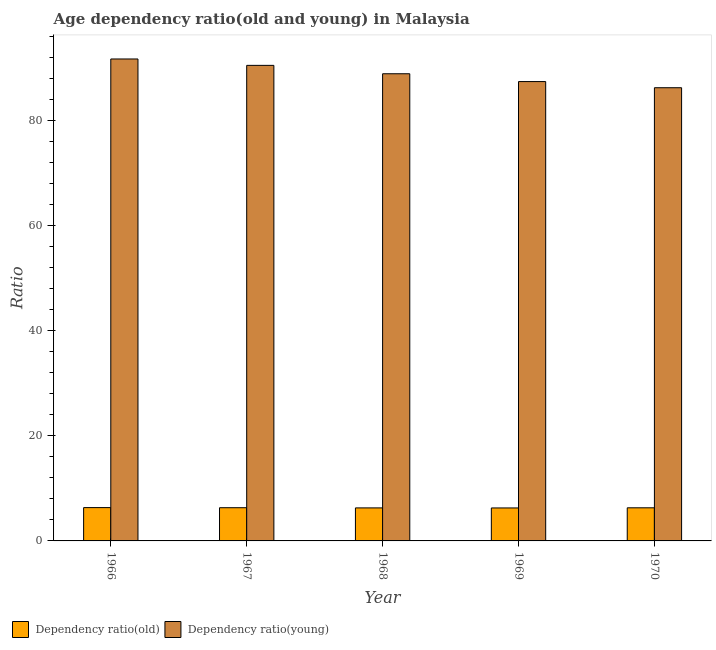How many groups of bars are there?
Ensure brevity in your answer.  5. Are the number of bars per tick equal to the number of legend labels?
Your answer should be compact. Yes. Are the number of bars on each tick of the X-axis equal?
Ensure brevity in your answer.  Yes. How many bars are there on the 3rd tick from the left?
Provide a short and direct response. 2. What is the label of the 1st group of bars from the left?
Your response must be concise. 1966. In how many cases, is the number of bars for a given year not equal to the number of legend labels?
Offer a terse response. 0. What is the age dependency ratio(old) in 1970?
Offer a very short reply. 6.3. Across all years, what is the maximum age dependency ratio(old)?
Your answer should be compact. 6.34. Across all years, what is the minimum age dependency ratio(old)?
Offer a very short reply. 6.27. In which year was the age dependency ratio(young) maximum?
Give a very brief answer. 1966. In which year was the age dependency ratio(old) minimum?
Offer a very short reply. 1969. What is the total age dependency ratio(young) in the graph?
Your response must be concise. 444.66. What is the difference between the age dependency ratio(young) in 1966 and that in 1969?
Provide a short and direct response. 4.3. What is the difference between the age dependency ratio(old) in 1969 and the age dependency ratio(young) in 1966?
Keep it short and to the point. -0.07. What is the average age dependency ratio(young) per year?
Ensure brevity in your answer.  88.93. In the year 1967, what is the difference between the age dependency ratio(old) and age dependency ratio(young)?
Offer a terse response. 0. What is the ratio of the age dependency ratio(young) in 1966 to that in 1969?
Your response must be concise. 1.05. Is the age dependency ratio(young) in 1966 less than that in 1969?
Your answer should be compact. No. Is the difference between the age dependency ratio(young) in 1968 and 1969 greater than the difference between the age dependency ratio(old) in 1968 and 1969?
Provide a short and direct response. No. What is the difference between the highest and the second highest age dependency ratio(old)?
Ensure brevity in your answer.  0.02. What is the difference between the highest and the lowest age dependency ratio(old)?
Offer a very short reply. 0.07. In how many years, is the age dependency ratio(old) greater than the average age dependency ratio(old) taken over all years?
Offer a very short reply. 2. Is the sum of the age dependency ratio(old) in 1966 and 1970 greater than the maximum age dependency ratio(young) across all years?
Your answer should be very brief. Yes. What does the 1st bar from the left in 1966 represents?
Your answer should be very brief. Dependency ratio(old). What does the 1st bar from the right in 1968 represents?
Your response must be concise. Dependency ratio(young). Does the graph contain any zero values?
Ensure brevity in your answer.  No. Does the graph contain grids?
Give a very brief answer. No. Where does the legend appear in the graph?
Your response must be concise. Bottom left. How many legend labels are there?
Your answer should be compact. 2. What is the title of the graph?
Ensure brevity in your answer.  Age dependency ratio(old and young) in Malaysia. What is the label or title of the X-axis?
Your answer should be compact. Year. What is the label or title of the Y-axis?
Ensure brevity in your answer.  Ratio. What is the Ratio of Dependency ratio(old) in 1966?
Make the answer very short. 6.34. What is the Ratio of Dependency ratio(young) in 1966?
Give a very brief answer. 91.69. What is the Ratio of Dependency ratio(old) in 1967?
Provide a short and direct response. 6.32. What is the Ratio in Dependency ratio(young) in 1967?
Your response must be concise. 90.48. What is the Ratio of Dependency ratio(old) in 1968?
Make the answer very short. 6.28. What is the Ratio of Dependency ratio(young) in 1968?
Offer a very short reply. 88.88. What is the Ratio of Dependency ratio(old) in 1969?
Your response must be concise. 6.27. What is the Ratio of Dependency ratio(young) in 1969?
Your answer should be compact. 87.39. What is the Ratio in Dependency ratio(old) in 1970?
Provide a succinct answer. 6.3. What is the Ratio of Dependency ratio(young) in 1970?
Ensure brevity in your answer.  86.22. Across all years, what is the maximum Ratio of Dependency ratio(old)?
Your response must be concise. 6.34. Across all years, what is the maximum Ratio in Dependency ratio(young)?
Provide a succinct answer. 91.69. Across all years, what is the minimum Ratio of Dependency ratio(old)?
Offer a terse response. 6.27. Across all years, what is the minimum Ratio in Dependency ratio(young)?
Your answer should be compact. 86.22. What is the total Ratio of Dependency ratio(old) in the graph?
Your answer should be very brief. 31.52. What is the total Ratio of Dependency ratio(young) in the graph?
Ensure brevity in your answer.  444.66. What is the difference between the Ratio in Dependency ratio(old) in 1966 and that in 1967?
Offer a very short reply. 0.02. What is the difference between the Ratio of Dependency ratio(young) in 1966 and that in 1967?
Your response must be concise. 1.22. What is the difference between the Ratio of Dependency ratio(old) in 1966 and that in 1968?
Offer a very short reply. 0.06. What is the difference between the Ratio in Dependency ratio(young) in 1966 and that in 1968?
Give a very brief answer. 2.81. What is the difference between the Ratio of Dependency ratio(old) in 1966 and that in 1969?
Your response must be concise. 0.07. What is the difference between the Ratio in Dependency ratio(young) in 1966 and that in 1969?
Your response must be concise. 4.3. What is the difference between the Ratio in Dependency ratio(old) in 1966 and that in 1970?
Provide a succinct answer. 0.04. What is the difference between the Ratio in Dependency ratio(young) in 1966 and that in 1970?
Your answer should be compact. 5.47. What is the difference between the Ratio in Dependency ratio(old) in 1967 and that in 1968?
Offer a terse response. 0.03. What is the difference between the Ratio of Dependency ratio(young) in 1967 and that in 1968?
Your response must be concise. 1.59. What is the difference between the Ratio in Dependency ratio(old) in 1967 and that in 1969?
Offer a terse response. 0.04. What is the difference between the Ratio of Dependency ratio(young) in 1967 and that in 1969?
Offer a very short reply. 3.08. What is the difference between the Ratio of Dependency ratio(old) in 1967 and that in 1970?
Make the answer very short. 0.02. What is the difference between the Ratio in Dependency ratio(young) in 1967 and that in 1970?
Ensure brevity in your answer.  4.25. What is the difference between the Ratio of Dependency ratio(old) in 1968 and that in 1969?
Ensure brevity in your answer.  0.01. What is the difference between the Ratio in Dependency ratio(young) in 1968 and that in 1969?
Give a very brief answer. 1.49. What is the difference between the Ratio of Dependency ratio(old) in 1968 and that in 1970?
Keep it short and to the point. -0.02. What is the difference between the Ratio of Dependency ratio(young) in 1968 and that in 1970?
Make the answer very short. 2.66. What is the difference between the Ratio in Dependency ratio(old) in 1969 and that in 1970?
Offer a terse response. -0.03. What is the difference between the Ratio in Dependency ratio(young) in 1969 and that in 1970?
Offer a terse response. 1.17. What is the difference between the Ratio of Dependency ratio(old) in 1966 and the Ratio of Dependency ratio(young) in 1967?
Your answer should be compact. -84.14. What is the difference between the Ratio in Dependency ratio(old) in 1966 and the Ratio in Dependency ratio(young) in 1968?
Offer a terse response. -82.54. What is the difference between the Ratio of Dependency ratio(old) in 1966 and the Ratio of Dependency ratio(young) in 1969?
Offer a very short reply. -81.05. What is the difference between the Ratio in Dependency ratio(old) in 1966 and the Ratio in Dependency ratio(young) in 1970?
Ensure brevity in your answer.  -79.88. What is the difference between the Ratio of Dependency ratio(old) in 1967 and the Ratio of Dependency ratio(young) in 1968?
Keep it short and to the point. -82.56. What is the difference between the Ratio in Dependency ratio(old) in 1967 and the Ratio in Dependency ratio(young) in 1969?
Your answer should be very brief. -81.07. What is the difference between the Ratio of Dependency ratio(old) in 1967 and the Ratio of Dependency ratio(young) in 1970?
Offer a terse response. -79.91. What is the difference between the Ratio in Dependency ratio(old) in 1968 and the Ratio in Dependency ratio(young) in 1969?
Provide a short and direct response. -81.11. What is the difference between the Ratio of Dependency ratio(old) in 1968 and the Ratio of Dependency ratio(young) in 1970?
Ensure brevity in your answer.  -79.94. What is the difference between the Ratio of Dependency ratio(old) in 1969 and the Ratio of Dependency ratio(young) in 1970?
Offer a terse response. -79.95. What is the average Ratio in Dependency ratio(old) per year?
Provide a succinct answer. 6.3. What is the average Ratio in Dependency ratio(young) per year?
Provide a succinct answer. 88.93. In the year 1966, what is the difference between the Ratio in Dependency ratio(old) and Ratio in Dependency ratio(young)?
Your answer should be very brief. -85.35. In the year 1967, what is the difference between the Ratio in Dependency ratio(old) and Ratio in Dependency ratio(young)?
Offer a very short reply. -84.16. In the year 1968, what is the difference between the Ratio in Dependency ratio(old) and Ratio in Dependency ratio(young)?
Your answer should be very brief. -82.6. In the year 1969, what is the difference between the Ratio of Dependency ratio(old) and Ratio of Dependency ratio(young)?
Your response must be concise. -81.12. In the year 1970, what is the difference between the Ratio of Dependency ratio(old) and Ratio of Dependency ratio(young)?
Provide a succinct answer. -79.92. What is the ratio of the Ratio in Dependency ratio(old) in 1966 to that in 1967?
Make the answer very short. 1. What is the ratio of the Ratio of Dependency ratio(young) in 1966 to that in 1967?
Offer a very short reply. 1.01. What is the ratio of the Ratio in Dependency ratio(young) in 1966 to that in 1968?
Your answer should be very brief. 1.03. What is the ratio of the Ratio of Dependency ratio(old) in 1966 to that in 1969?
Offer a very short reply. 1.01. What is the ratio of the Ratio of Dependency ratio(young) in 1966 to that in 1969?
Offer a very short reply. 1.05. What is the ratio of the Ratio in Dependency ratio(old) in 1966 to that in 1970?
Your answer should be very brief. 1.01. What is the ratio of the Ratio of Dependency ratio(young) in 1966 to that in 1970?
Your answer should be compact. 1.06. What is the ratio of the Ratio of Dependency ratio(young) in 1967 to that in 1968?
Offer a very short reply. 1.02. What is the ratio of the Ratio of Dependency ratio(old) in 1967 to that in 1969?
Your answer should be very brief. 1.01. What is the ratio of the Ratio in Dependency ratio(young) in 1967 to that in 1969?
Ensure brevity in your answer.  1.04. What is the ratio of the Ratio in Dependency ratio(young) in 1967 to that in 1970?
Your answer should be compact. 1.05. What is the ratio of the Ratio in Dependency ratio(old) in 1968 to that in 1970?
Provide a short and direct response. 1. What is the ratio of the Ratio of Dependency ratio(young) in 1968 to that in 1970?
Provide a short and direct response. 1.03. What is the ratio of the Ratio of Dependency ratio(young) in 1969 to that in 1970?
Offer a very short reply. 1.01. What is the difference between the highest and the second highest Ratio in Dependency ratio(old)?
Your response must be concise. 0.02. What is the difference between the highest and the second highest Ratio of Dependency ratio(young)?
Offer a terse response. 1.22. What is the difference between the highest and the lowest Ratio of Dependency ratio(old)?
Your answer should be very brief. 0.07. What is the difference between the highest and the lowest Ratio of Dependency ratio(young)?
Offer a terse response. 5.47. 